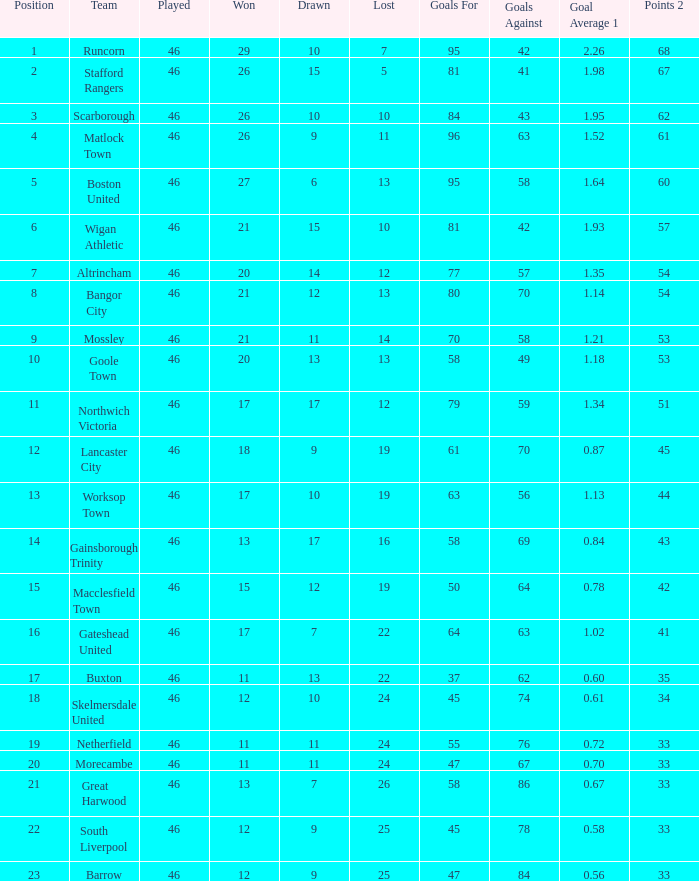34? Northwich Victoria. 